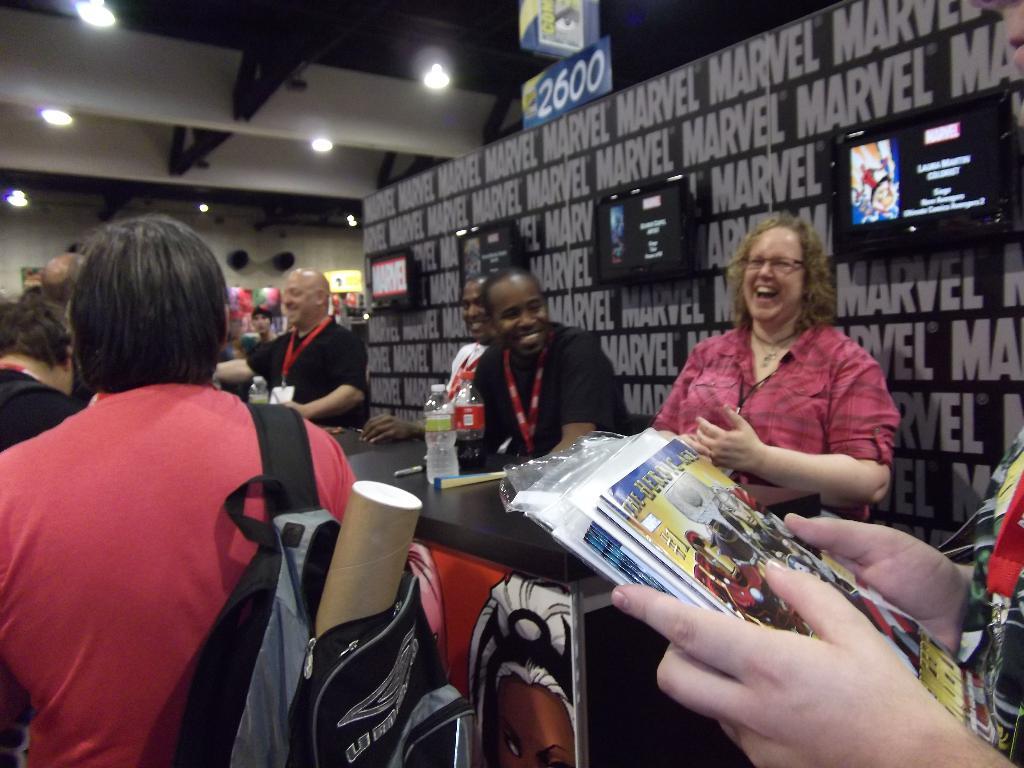What is marvel's booth number?
Provide a short and direct response. 2600. What comic book brand is featured?
Your response must be concise. Marvel. 